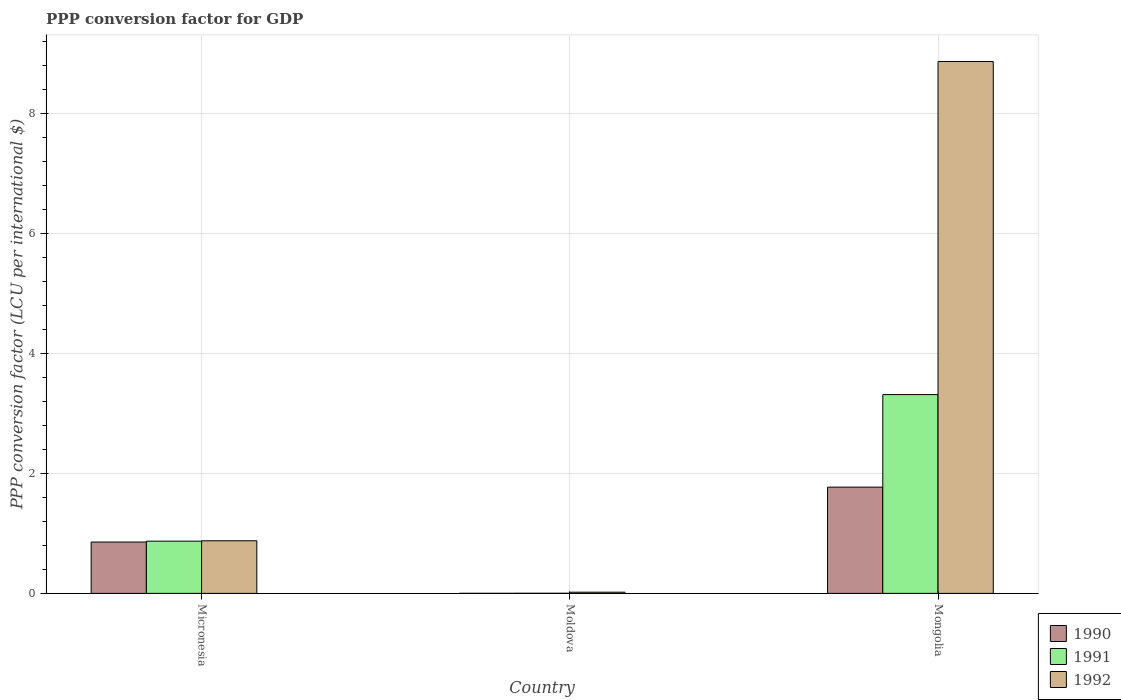How many different coloured bars are there?
Give a very brief answer. 3. How many groups of bars are there?
Keep it short and to the point. 3. Are the number of bars per tick equal to the number of legend labels?
Offer a terse response. Yes. Are the number of bars on each tick of the X-axis equal?
Offer a terse response. Yes. How many bars are there on the 1st tick from the right?
Make the answer very short. 3. What is the label of the 2nd group of bars from the left?
Offer a very short reply. Moldova. What is the PPP conversion factor for GDP in 1991 in Mongolia?
Make the answer very short. 3.31. Across all countries, what is the maximum PPP conversion factor for GDP in 1990?
Offer a very short reply. 1.77. Across all countries, what is the minimum PPP conversion factor for GDP in 1991?
Provide a short and direct response. 0. In which country was the PPP conversion factor for GDP in 1990 maximum?
Your answer should be very brief. Mongolia. In which country was the PPP conversion factor for GDP in 1991 minimum?
Offer a very short reply. Moldova. What is the total PPP conversion factor for GDP in 1991 in the graph?
Your response must be concise. 4.18. What is the difference between the PPP conversion factor for GDP in 1992 in Moldova and that in Mongolia?
Offer a very short reply. -8.84. What is the difference between the PPP conversion factor for GDP in 1992 in Micronesia and the PPP conversion factor for GDP in 1991 in Moldova?
Your answer should be very brief. 0.87. What is the average PPP conversion factor for GDP in 1990 per country?
Your response must be concise. 0.88. What is the difference between the PPP conversion factor for GDP of/in 1992 and PPP conversion factor for GDP of/in 1991 in Moldova?
Your answer should be very brief. 0.02. What is the ratio of the PPP conversion factor for GDP in 1991 in Micronesia to that in Moldova?
Offer a terse response. 448.68. Is the PPP conversion factor for GDP in 1990 in Micronesia less than that in Mongolia?
Offer a very short reply. Yes. What is the difference between the highest and the second highest PPP conversion factor for GDP in 1992?
Your answer should be very brief. 7.99. What is the difference between the highest and the lowest PPP conversion factor for GDP in 1990?
Your answer should be compact. 1.77. Is it the case that in every country, the sum of the PPP conversion factor for GDP in 1992 and PPP conversion factor for GDP in 1990 is greater than the PPP conversion factor for GDP in 1991?
Provide a succinct answer. Yes. Where does the legend appear in the graph?
Keep it short and to the point. Bottom right. How many legend labels are there?
Keep it short and to the point. 3. How are the legend labels stacked?
Your response must be concise. Vertical. What is the title of the graph?
Keep it short and to the point. PPP conversion factor for GDP. Does "1997" appear as one of the legend labels in the graph?
Keep it short and to the point. No. What is the label or title of the Y-axis?
Your answer should be compact. PPP conversion factor (LCU per international $). What is the PPP conversion factor (LCU per international $) of 1990 in Micronesia?
Offer a terse response. 0.86. What is the PPP conversion factor (LCU per international $) in 1991 in Micronesia?
Your answer should be very brief. 0.87. What is the PPP conversion factor (LCU per international $) in 1992 in Micronesia?
Your answer should be very brief. 0.88. What is the PPP conversion factor (LCU per international $) of 1990 in Moldova?
Your answer should be very brief. 0. What is the PPP conversion factor (LCU per international $) of 1991 in Moldova?
Make the answer very short. 0. What is the PPP conversion factor (LCU per international $) of 1992 in Moldova?
Give a very brief answer. 0.02. What is the PPP conversion factor (LCU per international $) of 1990 in Mongolia?
Your answer should be compact. 1.77. What is the PPP conversion factor (LCU per international $) in 1991 in Mongolia?
Give a very brief answer. 3.31. What is the PPP conversion factor (LCU per international $) in 1992 in Mongolia?
Offer a very short reply. 8.86. Across all countries, what is the maximum PPP conversion factor (LCU per international $) in 1990?
Your answer should be very brief. 1.77. Across all countries, what is the maximum PPP conversion factor (LCU per international $) of 1991?
Your answer should be very brief. 3.31. Across all countries, what is the maximum PPP conversion factor (LCU per international $) of 1992?
Your answer should be very brief. 8.86. Across all countries, what is the minimum PPP conversion factor (LCU per international $) in 1990?
Offer a terse response. 0. Across all countries, what is the minimum PPP conversion factor (LCU per international $) of 1991?
Keep it short and to the point. 0. Across all countries, what is the minimum PPP conversion factor (LCU per international $) of 1992?
Keep it short and to the point. 0.02. What is the total PPP conversion factor (LCU per international $) of 1990 in the graph?
Offer a very short reply. 2.63. What is the total PPP conversion factor (LCU per international $) in 1991 in the graph?
Give a very brief answer. 4.18. What is the total PPP conversion factor (LCU per international $) of 1992 in the graph?
Provide a short and direct response. 9.76. What is the difference between the PPP conversion factor (LCU per international $) in 1990 in Micronesia and that in Moldova?
Offer a very short reply. 0.85. What is the difference between the PPP conversion factor (LCU per international $) in 1991 in Micronesia and that in Moldova?
Make the answer very short. 0.87. What is the difference between the PPP conversion factor (LCU per international $) in 1992 in Micronesia and that in Moldova?
Offer a terse response. 0.86. What is the difference between the PPP conversion factor (LCU per international $) of 1990 in Micronesia and that in Mongolia?
Offer a terse response. -0.92. What is the difference between the PPP conversion factor (LCU per international $) of 1991 in Micronesia and that in Mongolia?
Provide a short and direct response. -2.44. What is the difference between the PPP conversion factor (LCU per international $) in 1992 in Micronesia and that in Mongolia?
Offer a terse response. -7.99. What is the difference between the PPP conversion factor (LCU per international $) in 1990 in Moldova and that in Mongolia?
Offer a very short reply. -1.77. What is the difference between the PPP conversion factor (LCU per international $) in 1991 in Moldova and that in Mongolia?
Ensure brevity in your answer.  -3.31. What is the difference between the PPP conversion factor (LCU per international $) in 1992 in Moldova and that in Mongolia?
Provide a succinct answer. -8.84. What is the difference between the PPP conversion factor (LCU per international $) in 1990 in Micronesia and the PPP conversion factor (LCU per international $) in 1991 in Moldova?
Provide a succinct answer. 0.85. What is the difference between the PPP conversion factor (LCU per international $) of 1990 in Micronesia and the PPP conversion factor (LCU per international $) of 1992 in Moldova?
Keep it short and to the point. 0.84. What is the difference between the PPP conversion factor (LCU per international $) of 1991 in Micronesia and the PPP conversion factor (LCU per international $) of 1992 in Moldova?
Give a very brief answer. 0.85. What is the difference between the PPP conversion factor (LCU per international $) in 1990 in Micronesia and the PPP conversion factor (LCU per international $) in 1991 in Mongolia?
Provide a succinct answer. -2.46. What is the difference between the PPP conversion factor (LCU per international $) of 1990 in Micronesia and the PPP conversion factor (LCU per international $) of 1992 in Mongolia?
Your response must be concise. -8.01. What is the difference between the PPP conversion factor (LCU per international $) of 1991 in Micronesia and the PPP conversion factor (LCU per international $) of 1992 in Mongolia?
Give a very brief answer. -7.99. What is the difference between the PPP conversion factor (LCU per international $) in 1990 in Moldova and the PPP conversion factor (LCU per international $) in 1991 in Mongolia?
Offer a terse response. -3.31. What is the difference between the PPP conversion factor (LCU per international $) in 1990 in Moldova and the PPP conversion factor (LCU per international $) in 1992 in Mongolia?
Provide a short and direct response. -8.86. What is the difference between the PPP conversion factor (LCU per international $) in 1991 in Moldova and the PPP conversion factor (LCU per international $) in 1992 in Mongolia?
Give a very brief answer. -8.86. What is the average PPP conversion factor (LCU per international $) in 1990 per country?
Provide a succinct answer. 0.88. What is the average PPP conversion factor (LCU per international $) of 1991 per country?
Your answer should be very brief. 1.4. What is the average PPP conversion factor (LCU per international $) in 1992 per country?
Your answer should be compact. 3.25. What is the difference between the PPP conversion factor (LCU per international $) in 1990 and PPP conversion factor (LCU per international $) in 1991 in Micronesia?
Provide a succinct answer. -0.01. What is the difference between the PPP conversion factor (LCU per international $) of 1990 and PPP conversion factor (LCU per international $) of 1992 in Micronesia?
Keep it short and to the point. -0.02. What is the difference between the PPP conversion factor (LCU per international $) in 1991 and PPP conversion factor (LCU per international $) in 1992 in Micronesia?
Offer a terse response. -0.01. What is the difference between the PPP conversion factor (LCU per international $) of 1990 and PPP conversion factor (LCU per international $) of 1991 in Moldova?
Your response must be concise. -0. What is the difference between the PPP conversion factor (LCU per international $) of 1990 and PPP conversion factor (LCU per international $) of 1992 in Moldova?
Make the answer very short. -0.02. What is the difference between the PPP conversion factor (LCU per international $) of 1991 and PPP conversion factor (LCU per international $) of 1992 in Moldova?
Keep it short and to the point. -0.02. What is the difference between the PPP conversion factor (LCU per international $) in 1990 and PPP conversion factor (LCU per international $) in 1991 in Mongolia?
Your answer should be compact. -1.54. What is the difference between the PPP conversion factor (LCU per international $) in 1990 and PPP conversion factor (LCU per international $) in 1992 in Mongolia?
Give a very brief answer. -7.09. What is the difference between the PPP conversion factor (LCU per international $) in 1991 and PPP conversion factor (LCU per international $) in 1992 in Mongolia?
Your answer should be compact. -5.55. What is the ratio of the PPP conversion factor (LCU per international $) in 1990 in Micronesia to that in Moldova?
Provide a short and direct response. 1023.83. What is the ratio of the PPP conversion factor (LCU per international $) of 1991 in Micronesia to that in Moldova?
Ensure brevity in your answer.  448.68. What is the ratio of the PPP conversion factor (LCU per international $) of 1992 in Micronesia to that in Moldova?
Offer a terse response. 44.24. What is the ratio of the PPP conversion factor (LCU per international $) in 1990 in Micronesia to that in Mongolia?
Give a very brief answer. 0.48. What is the ratio of the PPP conversion factor (LCU per international $) in 1991 in Micronesia to that in Mongolia?
Provide a short and direct response. 0.26. What is the ratio of the PPP conversion factor (LCU per international $) in 1992 in Micronesia to that in Mongolia?
Make the answer very short. 0.1. What is the ratio of the PPP conversion factor (LCU per international $) in 1990 in Moldova to that in Mongolia?
Your answer should be very brief. 0. What is the ratio of the PPP conversion factor (LCU per international $) in 1991 in Moldova to that in Mongolia?
Offer a very short reply. 0. What is the ratio of the PPP conversion factor (LCU per international $) of 1992 in Moldova to that in Mongolia?
Give a very brief answer. 0. What is the difference between the highest and the second highest PPP conversion factor (LCU per international $) of 1990?
Give a very brief answer. 0.92. What is the difference between the highest and the second highest PPP conversion factor (LCU per international $) of 1991?
Provide a succinct answer. 2.44. What is the difference between the highest and the second highest PPP conversion factor (LCU per international $) of 1992?
Your response must be concise. 7.99. What is the difference between the highest and the lowest PPP conversion factor (LCU per international $) in 1990?
Your response must be concise. 1.77. What is the difference between the highest and the lowest PPP conversion factor (LCU per international $) in 1991?
Keep it short and to the point. 3.31. What is the difference between the highest and the lowest PPP conversion factor (LCU per international $) of 1992?
Your answer should be very brief. 8.84. 